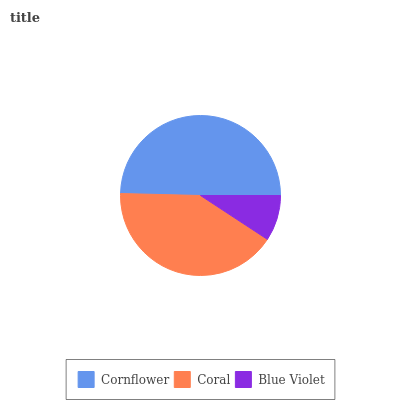Is Blue Violet the minimum?
Answer yes or no. Yes. Is Cornflower the maximum?
Answer yes or no. Yes. Is Coral the minimum?
Answer yes or no. No. Is Coral the maximum?
Answer yes or no. No. Is Cornflower greater than Coral?
Answer yes or no. Yes. Is Coral less than Cornflower?
Answer yes or no. Yes. Is Coral greater than Cornflower?
Answer yes or no. No. Is Cornflower less than Coral?
Answer yes or no. No. Is Coral the high median?
Answer yes or no. Yes. Is Coral the low median?
Answer yes or no. Yes. Is Blue Violet the high median?
Answer yes or no. No. Is Blue Violet the low median?
Answer yes or no. No. 